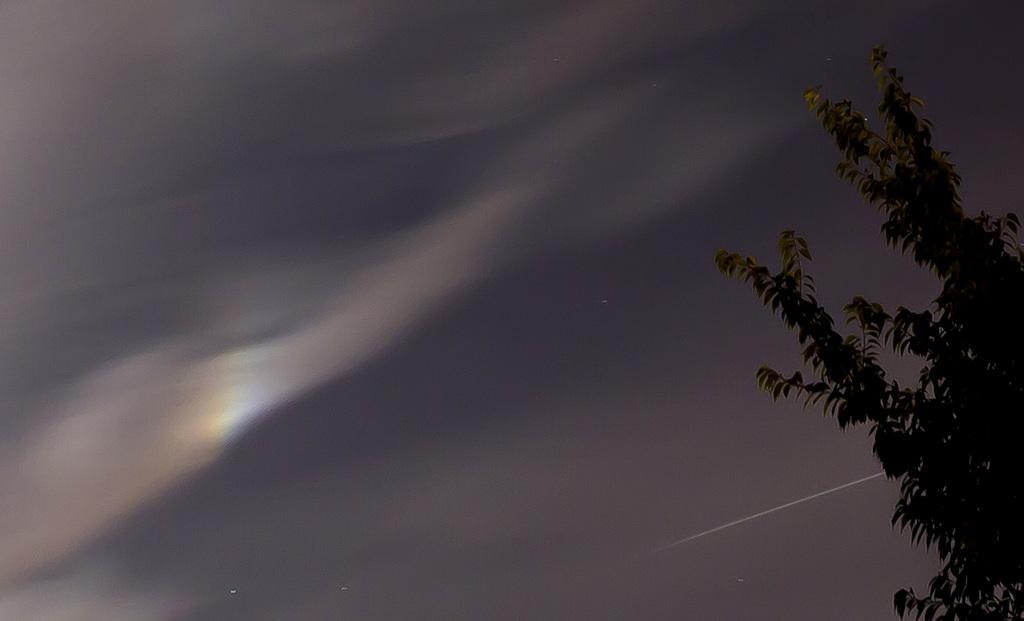What type of vegetation is on the right side of the image? There is a tree at the right side of the image. What is the condition of the sky in the image? The sky is cloudy in the image. What type of furniture is being attacked by the cloud in the image? There is no furniture present in the image, nor is there any indication of an attack. 